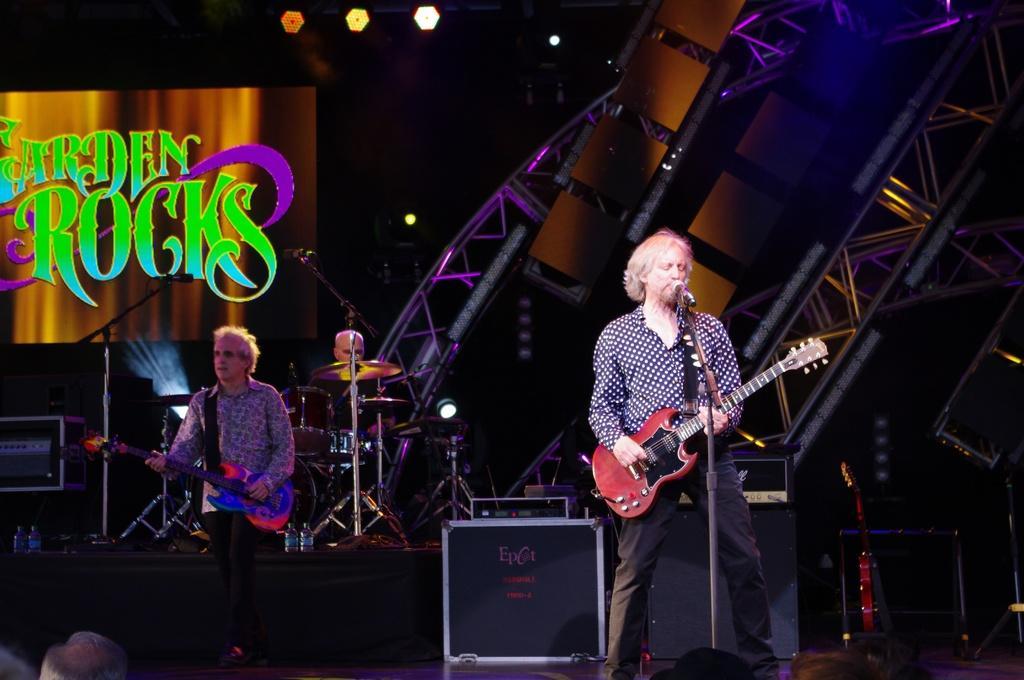Describe this image in one or two sentences. This picture is clicked in a musical concert. Man in the middle of the picture wearing blue shirt is holding a guitar in his hands and playing it and he is even singing on microphone. Man on the left corner of the picture wearing grey shirt is also holding guitar in his hands. Behind him, we see man playing drums and on the left top of the picture, we see a board on which "Garden rocks" is written. On the top of the picture, we see lights. 